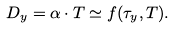Convert formula to latex. <formula><loc_0><loc_0><loc_500><loc_500>D _ { y } = \alpha \cdot T \simeq f ( \tau _ { y } , T ) .</formula> 